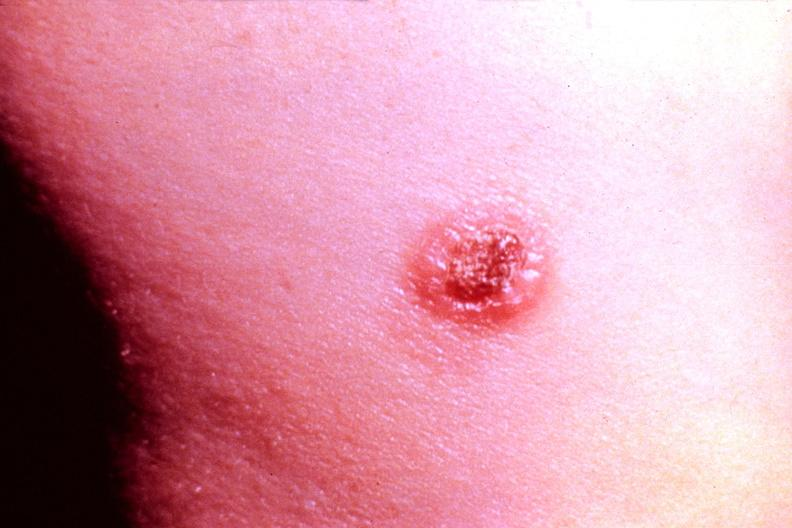where is this?
Answer the question using a single word or phrase. Skin 